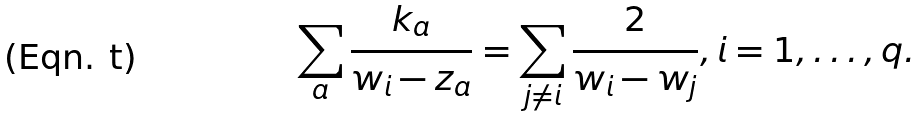<formula> <loc_0><loc_0><loc_500><loc_500>\sum _ { a } \frac { k _ { a } } { w _ { i } - z _ { a } } = \sum _ { j \not = i } \frac { 2 } { w _ { i } - w _ { j } } , i = 1 , \dots , q .</formula> 